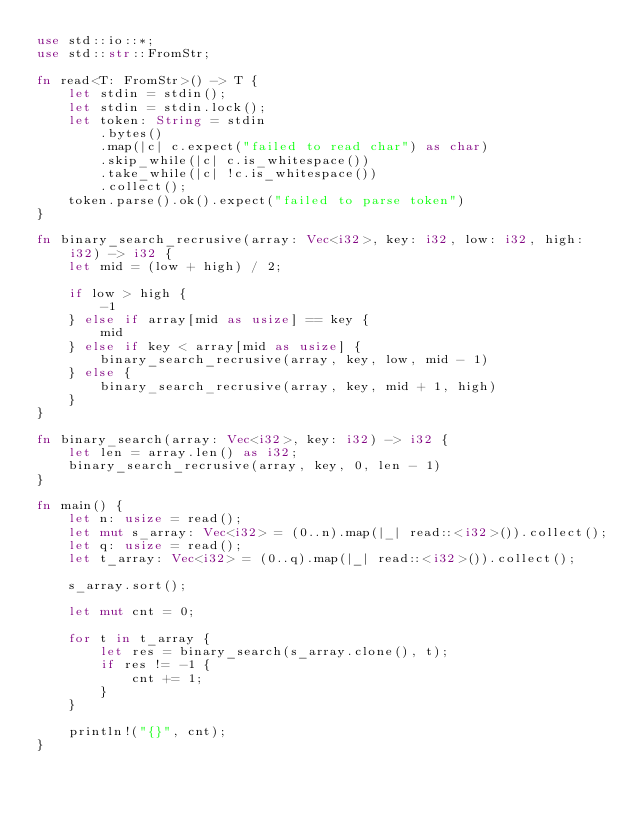Convert code to text. <code><loc_0><loc_0><loc_500><loc_500><_Rust_>use std::io::*;
use std::str::FromStr;

fn read<T: FromStr>() -> T {
    let stdin = stdin();
    let stdin = stdin.lock();
    let token: String = stdin
        .bytes()
        .map(|c| c.expect("failed to read char") as char)
        .skip_while(|c| c.is_whitespace())
        .take_while(|c| !c.is_whitespace())
        .collect();
    token.parse().ok().expect("failed to parse token")
}

fn binary_search_recrusive(array: Vec<i32>, key: i32, low: i32, high: i32) -> i32 {
    let mid = (low + high) / 2;

    if low > high {
        -1
    } else if array[mid as usize] == key {
        mid
    } else if key < array[mid as usize] {
        binary_search_recrusive(array, key, low, mid - 1)
    } else {
        binary_search_recrusive(array, key, mid + 1, high)
    }
}

fn binary_search(array: Vec<i32>, key: i32) -> i32 {
    let len = array.len() as i32;
    binary_search_recrusive(array, key, 0, len - 1)
}

fn main() {
    let n: usize = read();
    let mut s_array: Vec<i32> = (0..n).map(|_| read::<i32>()).collect();
    let q: usize = read();
    let t_array: Vec<i32> = (0..q).map(|_| read::<i32>()).collect();

    s_array.sort();

    let mut cnt = 0;

    for t in t_array {
        let res = binary_search(s_array.clone(), t);
        if res != -1 {
            cnt += 1;
        }
    }

    println!("{}", cnt);
}

</code> 